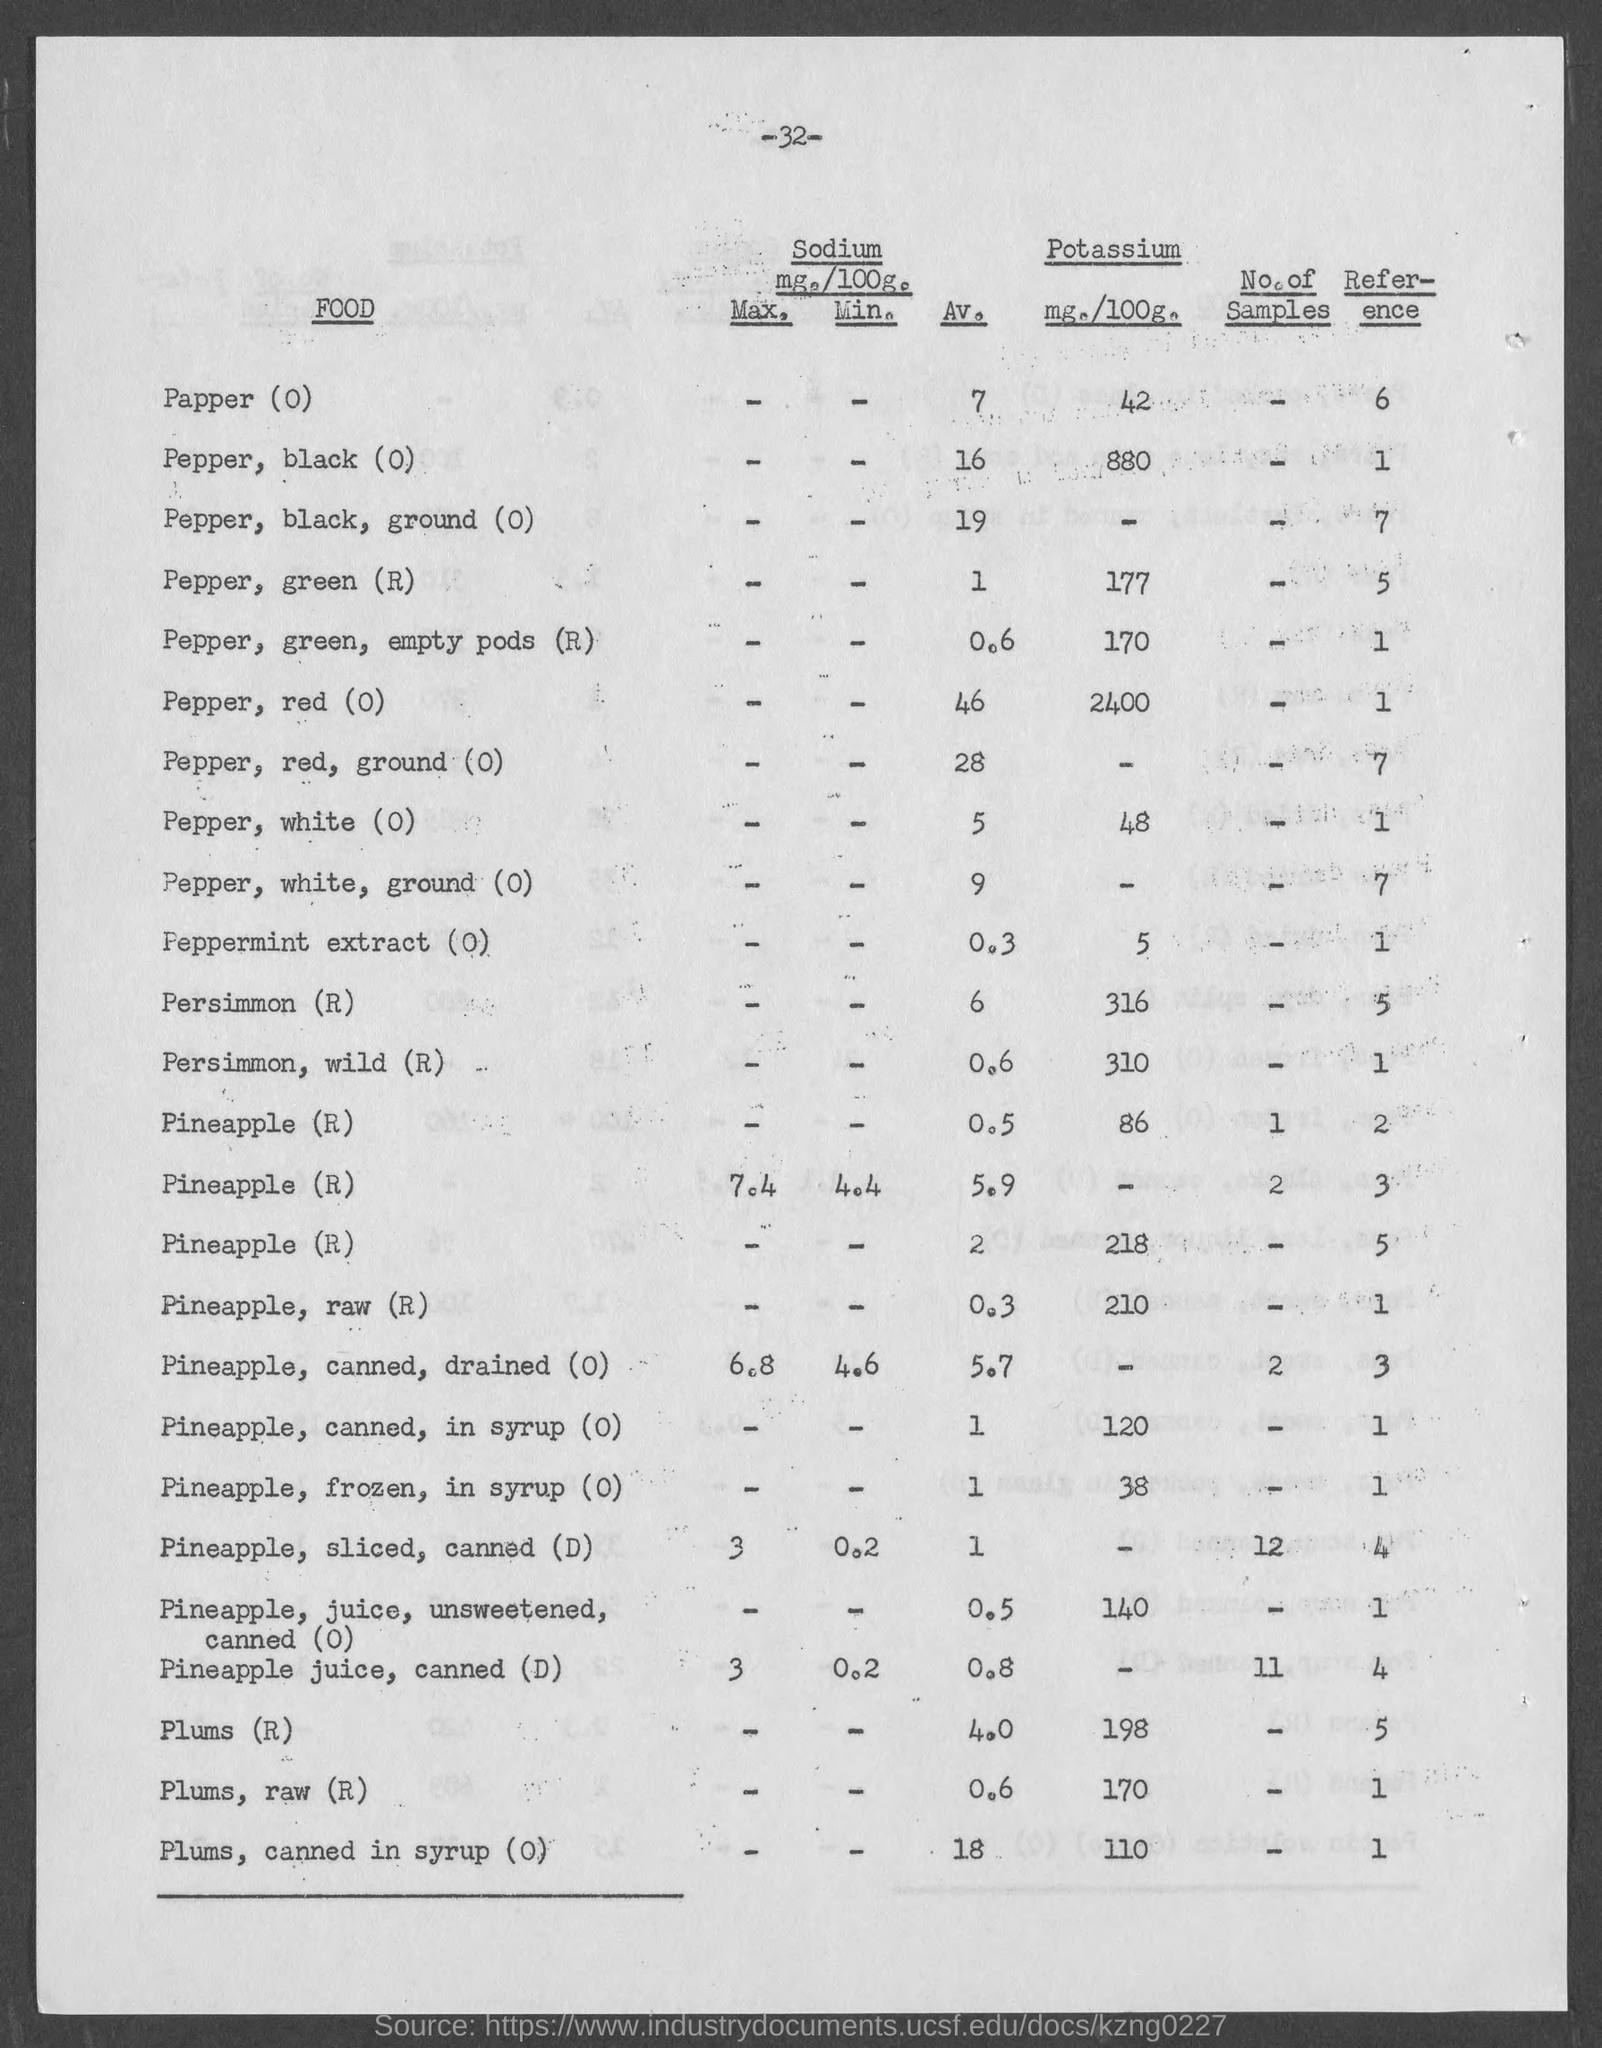What is the page no mentioned in this document?
Ensure brevity in your answer.  32. What is the average amount of sodium (mg./100g.) present in Persimmon (R)?
Your answer should be compact. 6. What is the average amount of sodium (mg./100g.) present in Pepper, red (0)?
Your response must be concise. 46. What is the amount of Pottasium (mg./100g.) present in Pepper, black (0)?
Your answer should be compact. 880. What is the amount of Pottasium (mg./100g.) present in Pineapple, raw (R)?
Your answer should be compact. 210. What is the average amount of sodium (mg./100g.) present in Plums (R)?
Provide a succinct answer. 4.0. What is the amount of Pottasium (mg./100g.) present in Plums, raw (R)?
Provide a succinct answer. 170. 